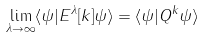Convert formula to latex. <formula><loc_0><loc_0><loc_500><loc_500>\lim _ { \lambda \to \infty } \langle \psi | E ^ { \lambda } [ k ] \psi \rangle = \langle \psi | Q ^ { k } \psi \rangle</formula> 